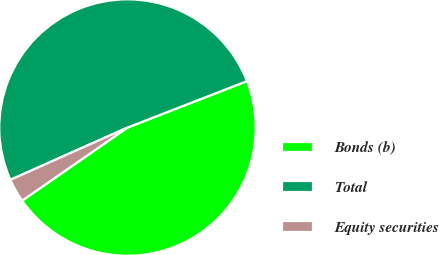Convert chart to OTSL. <chart><loc_0><loc_0><loc_500><loc_500><pie_chart><fcel>Bonds (b)<fcel>Total<fcel>Equity securities<nl><fcel>46.25%<fcel>50.78%<fcel>2.97%<nl></chart> 